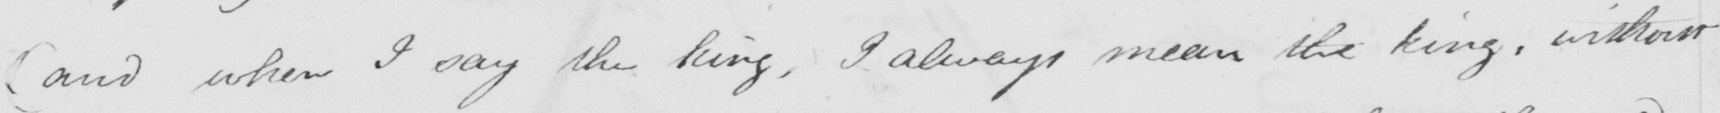What text is written in this handwritten line? ( and when I say the king , I always mean the king , without 